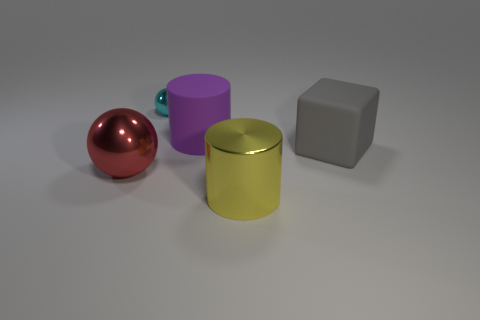Add 5 green metallic cylinders. How many objects exist? 10 Subtract all blocks. How many objects are left? 4 Subtract 1 balls. How many balls are left? 1 Subtract all yellow cylinders. Subtract all large yellow shiny things. How many objects are left? 3 Add 2 gray matte cubes. How many gray matte cubes are left? 3 Add 2 tiny cyan things. How many tiny cyan things exist? 3 Subtract 0 yellow blocks. How many objects are left? 5 Subtract all gray spheres. Subtract all yellow cylinders. How many spheres are left? 2 Subtract all blue spheres. How many yellow cylinders are left? 1 